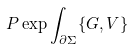<formula> <loc_0><loc_0><loc_500><loc_500>P \exp \int _ { \partial \Sigma } \{ G , V \}</formula> 